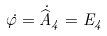<formula> <loc_0><loc_0><loc_500><loc_500>\dot { \varphi } = \dot { \widehat { A } } _ { 4 } = E _ { 4 }</formula> 